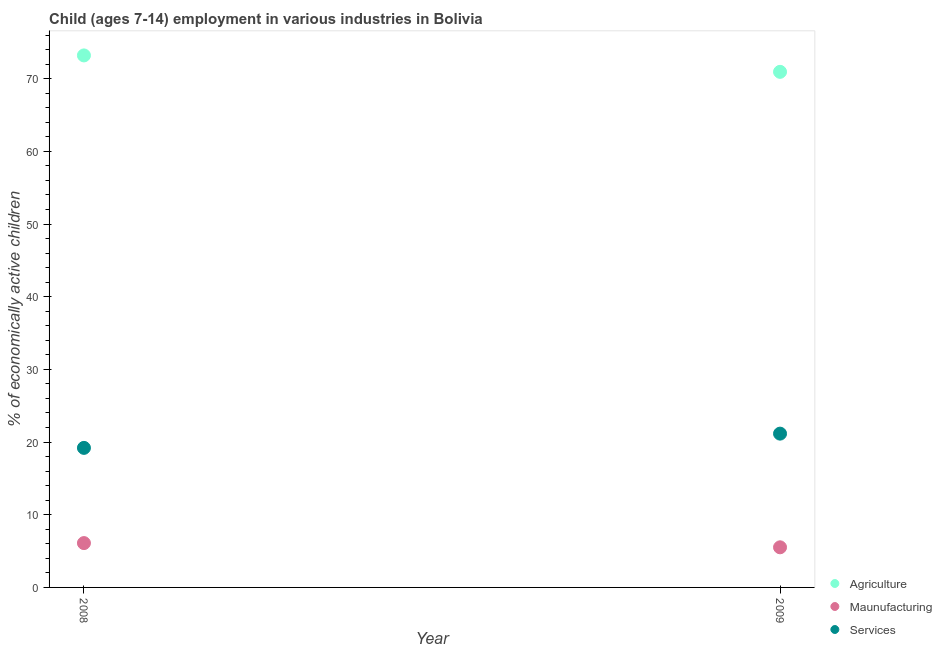How many different coloured dotlines are there?
Keep it short and to the point. 3. Is the number of dotlines equal to the number of legend labels?
Offer a very short reply. Yes. What is the percentage of economically active children in services in 2009?
Offer a very short reply. 21.16. Across all years, what is the maximum percentage of economically active children in manufacturing?
Provide a succinct answer. 6.1. Across all years, what is the minimum percentage of economically active children in manufacturing?
Keep it short and to the point. 5.52. What is the total percentage of economically active children in agriculture in the graph?
Your response must be concise. 144.14. What is the difference between the percentage of economically active children in manufacturing in 2008 and that in 2009?
Your answer should be compact. 0.58. What is the difference between the percentage of economically active children in services in 2009 and the percentage of economically active children in agriculture in 2008?
Your answer should be very brief. -52.04. What is the average percentage of economically active children in services per year?
Your answer should be very brief. 20.18. In the year 2009, what is the difference between the percentage of economically active children in manufacturing and percentage of economically active children in agriculture?
Provide a short and direct response. -65.42. What is the ratio of the percentage of economically active children in agriculture in 2008 to that in 2009?
Your response must be concise. 1.03. In how many years, is the percentage of economically active children in agriculture greater than the average percentage of economically active children in agriculture taken over all years?
Your answer should be compact. 1. How many dotlines are there?
Make the answer very short. 3. How many years are there in the graph?
Ensure brevity in your answer.  2. Are the values on the major ticks of Y-axis written in scientific E-notation?
Provide a succinct answer. No. Where does the legend appear in the graph?
Provide a succinct answer. Bottom right. How many legend labels are there?
Provide a succinct answer. 3. How are the legend labels stacked?
Your answer should be compact. Vertical. What is the title of the graph?
Provide a succinct answer. Child (ages 7-14) employment in various industries in Bolivia. What is the label or title of the X-axis?
Your answer should be very brief. Year. What is the label or title of the Y-axis?
Your answer should be compact. % of economically active children. What is the % of economically active children of Agriculture in 2008?
Your answer should be compact. 73.2. What is the % of economically active children of Maunufacturing in 2008?
Your response must be concise. 6.1. What is the % of economically active children in Services in 2008?
Offer a terse response. 19.2. What is the % of economically active children of Agriculture in 2009?
Your answer should be compact. 70.94. What is the % of economically active children in Maunufacturing in 2009?
Your response must be concise. 5.52. What is the % of economically active children of Services in 2009?
Give a very brief answer. 21.16. Across all years, what is the maximum % of economically active children of Agriculture?
Offer a terse response. 73.2. Across all years, what is the maximum % of economically active children in Maunufacturing?
Ensure brevity in your answer.  6.1. Across all years, what is the maximum % of economically active children in Services?
Offer a terse response. 21.16. Across all years, what is the minimum % of economically active children of Agriculture?
Provide a short and direct response. 70.94. Across all years, what is the minimum % of economically active children in Maunufacturing?
Keep it short and to the point. 5.52. Across all years, what is the minimum % of economically active children of Services?
Provide a short and direct response. 19.2. What is the total % of economically active children in Agriculture in the graph?
Offer a terse response. 144.14. What is the total % of economically active children in Maunufacturing in the graph?
Keep it short and to the point. 11.62. What is the total % of economically active children of Services in the graph?
Provide a short and direct response. 40.36. What is the difference between the % of economically active children in Agriculture in 2008 and that in 2009?
Ensure brevity in your answer.  2.26. What is the difference between the % of economically active children of Maunufacturing in 2008 and that in 2009?
Offer a very short reply. 0.58. What is the difference between the % of economically active children in Services in 2008 and that in 2009?
Give a very brief answer. -1.96. What is the difference between the % of economically active children in Agriculture in 2008 and the % of economically active children in Maunufacturing in 2009?
Keep it short and to the point. 67.68. What is the difference between the % of economically active children of Agriculture in 2008 and the % of economically active children of Services in 2009?
Offer a terse response. 52.04. What is the difference between the % of economically active children in Maunufacturing in 2008 and the % of economically active children in Services in 2009?
Your response must be concise. -15.06. What is the average % of economically active children of Agriculture per year?
Offer a terse response. 72.07. What is the average % of economically active children of Maunufacturing per year?
Make the answer very short. 5.81. What is the average % of economically active children of Services per year?
Your response must be concise. 20.18. In the year 2008, what is the difference between the % of economically active children of Agriculture and % of economically active children of Maunufacturing?
Your answer should be compact. 67.1. In the year 2008, what is the difference between the % of economically active children of Agriculture and % of economically active children of Services?
Make the answer very short. 54. In the year 2008, what is the difference between the % of economically active children in Maunufacturing and % of economically active children in Services?
Provide a succinct answer. -13.1. In the year 2009, what is the difference between the % of economically active children in Agriculture and % of economically active children in Maunufacturing?
Your answer should be compact. 65.42. In the year 2009, what is the difference between the % of economically active children of Agriculture and % of economically active children of Services?
Provide a short and direct response. 49.78. In the year 2009, what is the difference between the % of economically active children in Maunufacturing and % of economically active children in Services?
Provide a succinct answer. -15.64. What is the ratio of the % of economically active children of Agriculture in 2008 to that in 2009?
Offer a very short reply. 1.03. What is the ratio of the % of economically active children of Maunufacturing in 2008 to that in 2009?
Provide a short and direct response. 1.11. What is the ratio of the % of economically active children of Services in 2008 to that in 2009?
Offer a terse response. 0.91. What is the difference between the highest and the second highest % of economically active children in Agriculture?
Offer a terse response. 2.26. What is the difference between the highest and the second highest % of economically active children in Maunufacturing?
Offer a terse response. 0.58. What is the difference between the highest and the second highest % of economically active children of Services?
Your response must be concise. 1.96. What is the difference between the highest and the lowest % of economically active children of Agriculture?
Offer a terse response. 2.26. What is the difference between the highest and the lowest % of economically active children in Maunufacturing?
Your answer should be compact. 0.58. What is the difference between the highest and the lowest % of economically active children of Services?
Your answer should be very brief. 1.96. 